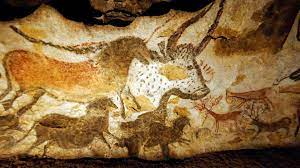What is this photo about? The image features the renowned Lascaux Caves in France, a treasure trove of prehistoric art. The walls of these caves are adorned with intricate paintings that depict various animals like horses, deer, and bulls, using earthy tones of red, orange, and white. Captured from a lower viewpoint, the photo reveals the expansive scale and artistic sophistication of these ancient artworks, highlighting their preservation state and the fading effects of time. This visual marvel not only offers a glimpse into the artistic practices of early humans but also reflects the importance of preservation and study in understanding our ancestral heritage. 